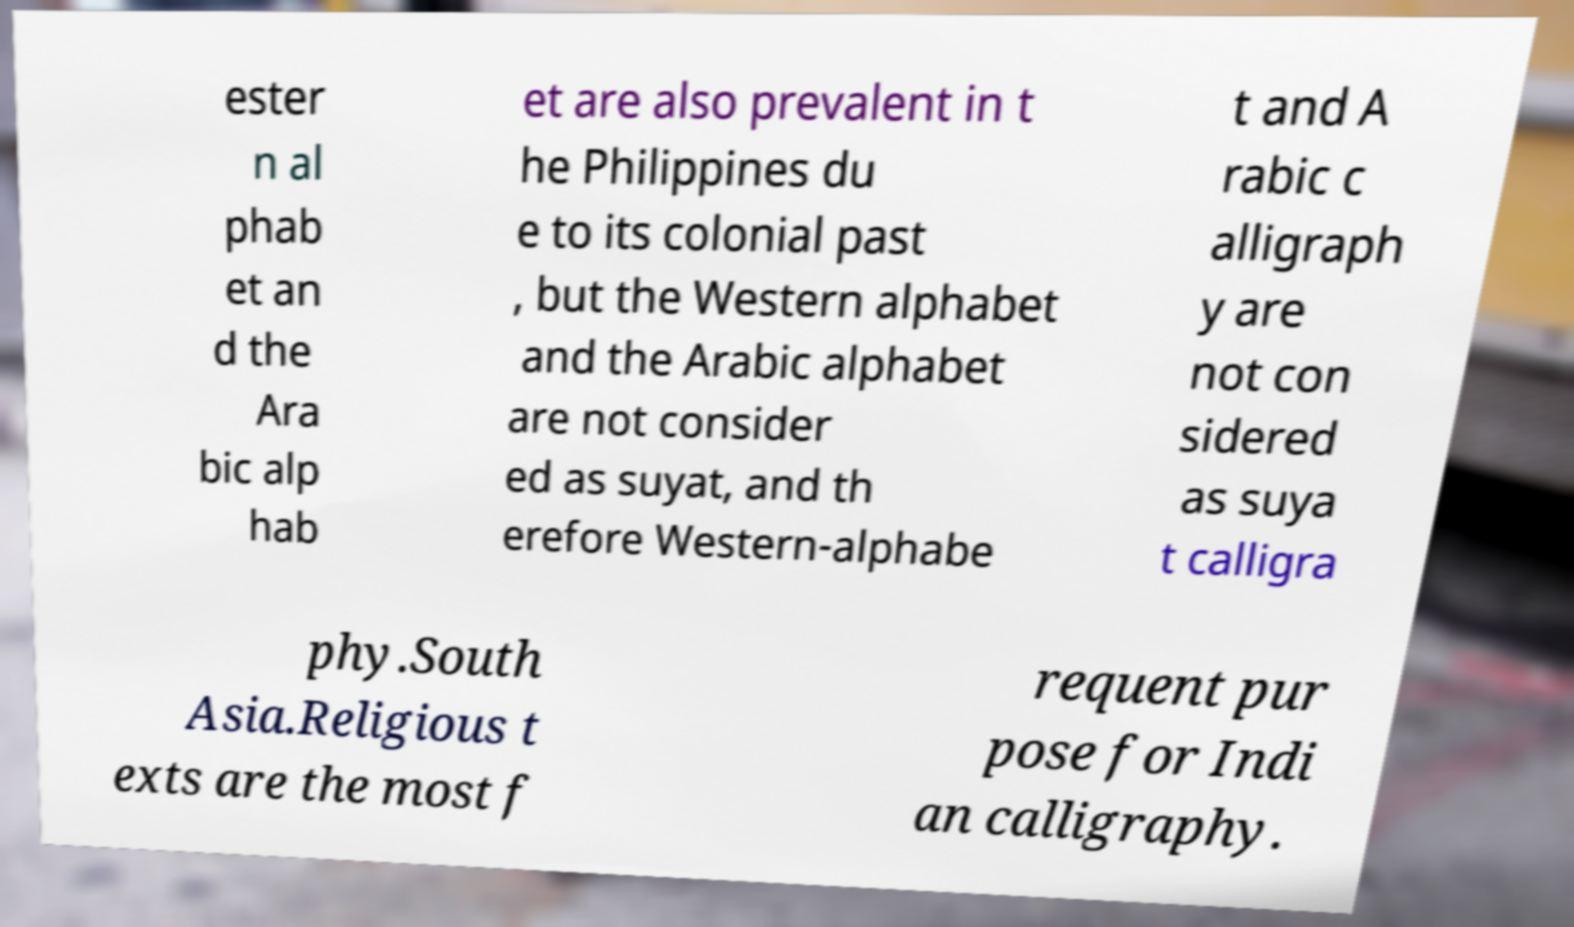Please identify and transcribe the text found in this image. ester n al phab et an d the Ara bic alp hab et are also prevalent in t he Philippines du e to its colonial past , but the Western alphabet and the Arabic alphabet are not consider ed as suyat, and th erefore Western-alphabe t and A rabic c alligraph y are not con sidered as suya t calligra phy.South Asia.Religious t exts are the most f requent pur pose for Indi an calligraphy. 